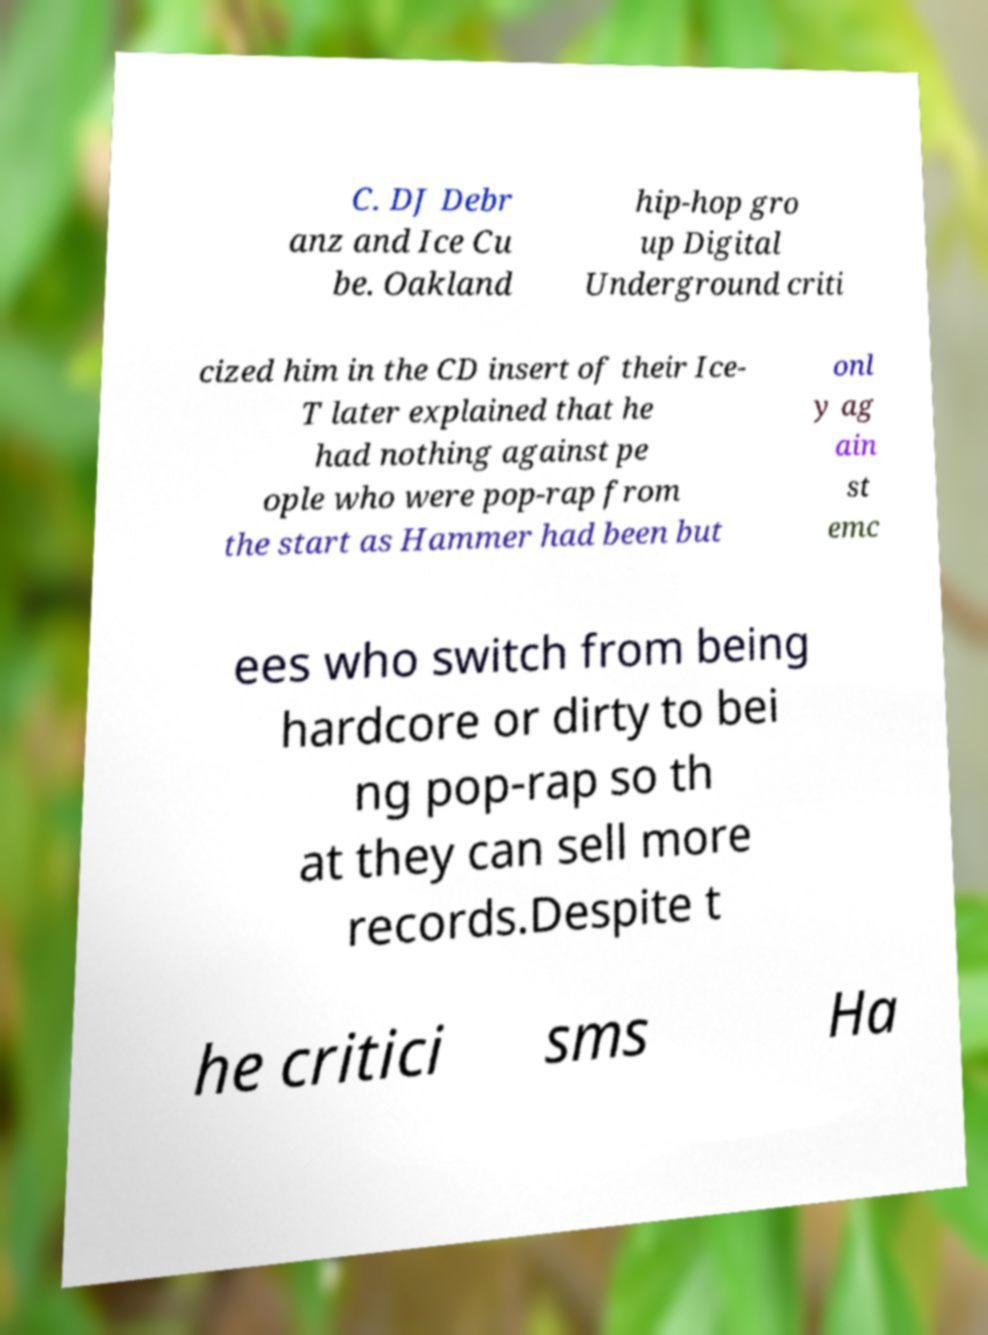Could you extract and type out the text from this image? C. DJ Debr anz and Ice Cu be. Oakland hip-hop gro up Digital Underground criti cized him in the CD insert of their Ice- T later explained that he had nothing against pe ople who were pop-rap from the start as Hammer had been but onl y ag ain st emc ees who switch from being hardcore or dirty to bei ng pop-rap so th at they can sell more records.Despite t he critici sms Ha 